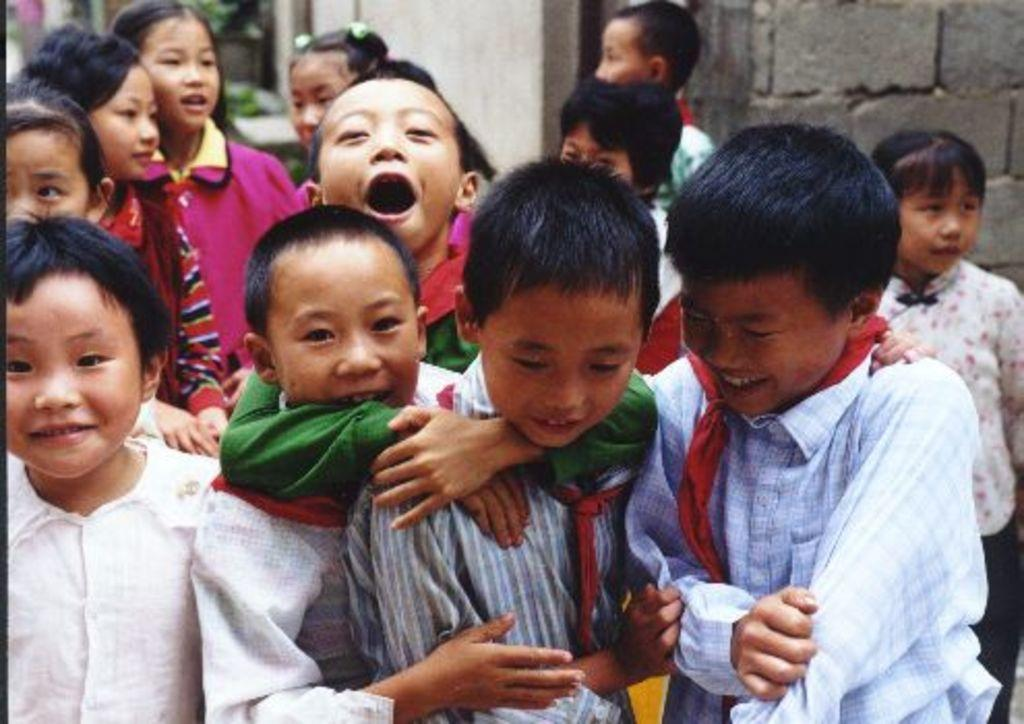What can be seen in the image? There are kids standing in the image. What is in the background of the image? There is a wall visible in the image. How many birds are flying over the kids in the image? There are no birds visible in the image; it only shows kids standing and a wall in the background. 